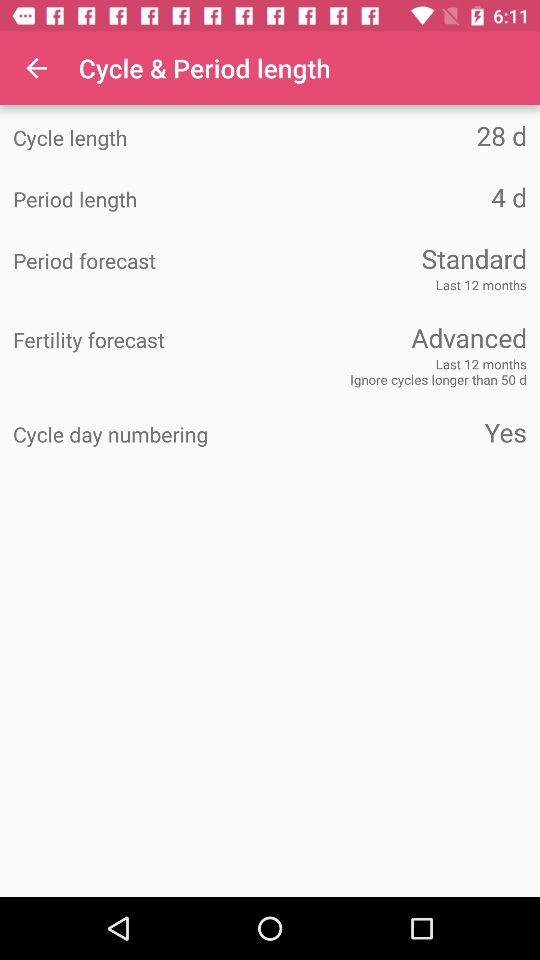What is the period length? The period length is 4 days. 